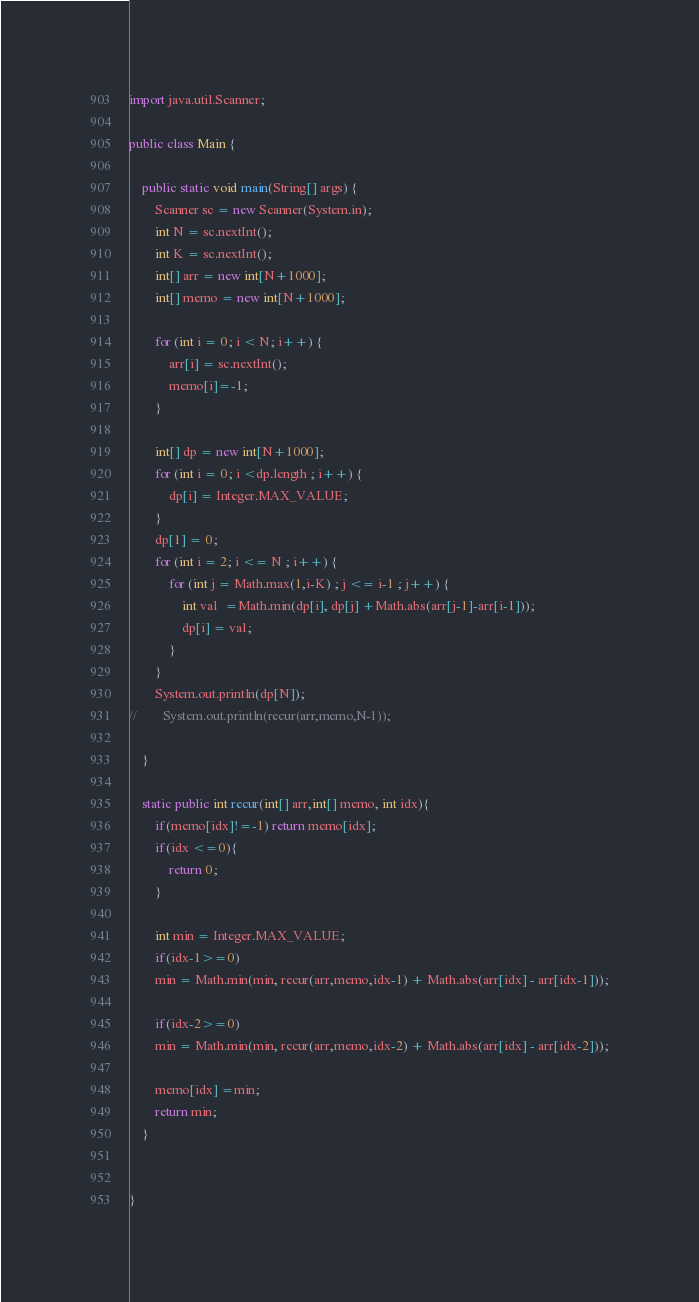<code> <loc_0><loc_0><loc_500><loc_500><_Java_>import java.util.Scanner;

public class Main {

    public static void main(String[] args) {
        Scanner sc = new Scanner(System.in);
        int N = sc.nextInt();
        int K = sc.nextInt();
        int[] arr = new int[N+1000];
        int[] memo = new int[N+1000];

        for (int i = 0; i < N; i++) {
            arr[i] = sc.nextInt();
            memo[i]=-1;
        }

        int[] dp = new int[N+1000];
        for (int i = 0; i <dp.length ; i++) {
            dp[i] = Integer.MAX_VALUE;
        }
        dp[1] = 0;
        for (int i = 2; i <= N ; i++) {
            for (int j = Math.max(1,i-K) ; j <= i-1 ; j++) {
                int val  =Math.min(dp[i], dp[j] +Math.abs(arr[j-1]-arr[i-1]));
                dp[i] = val;
            }
        }
        System.out.println(dp[N]);
//        System.out.println(recur(arr,memo,N-1));

    }

    static public int recur(int[] arr,int[] memo, int idx){
        if(memo[idx]!=-1) return memo[idx];
        if(idx <=0){
            return 0;
        }

        int min = Integer.MAX_VALUE;
        if(idx-1>=0)
        min = Math.min(min, recur(arr,memo,idx-1) + Math.abs(arr[idx] - arr[idx-1]));

        if(idx-2>=0)
        min = Math.min(min, recur(arr,memo,idx-2) + Math.abs(arr[idx] - arr[idx-2]));

        memo[idx] =min;
        return min;
    }


}

</code> 